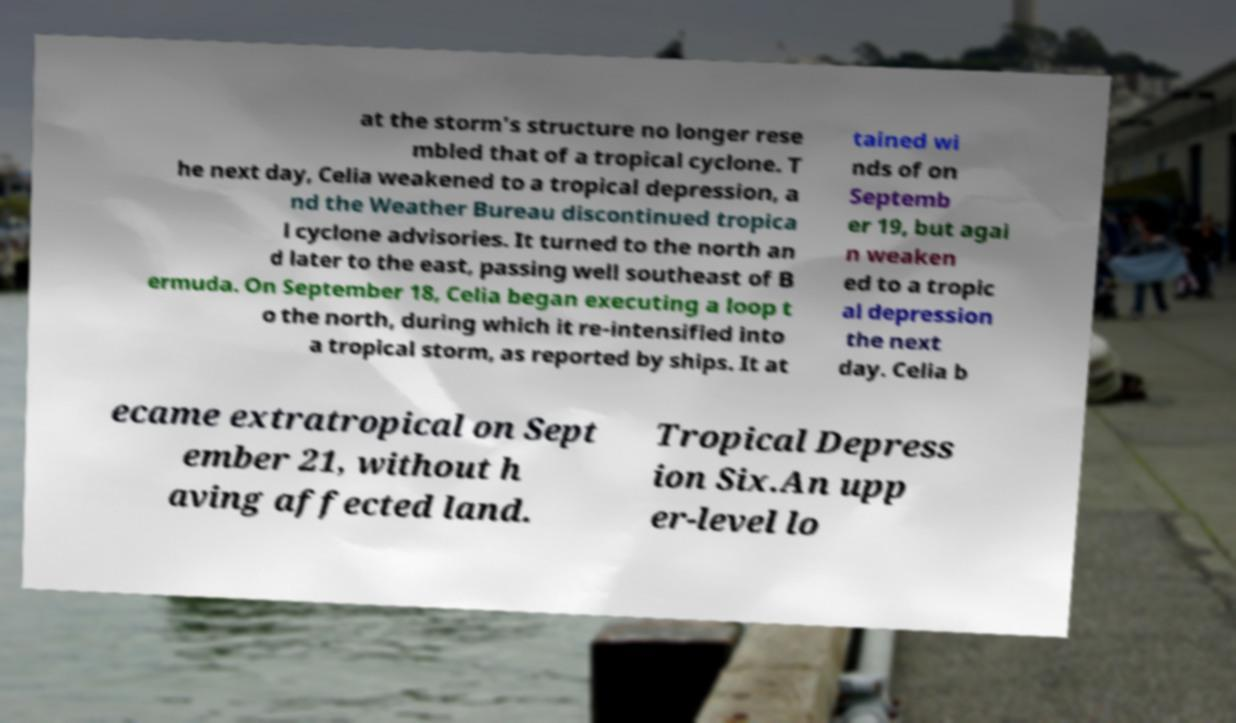Please identify and transcribe the text found in this image. at the storm's structure no longer rese mbled that of a tropical cyclone. T he next day, Celia weakened to a tropical depression, a nd the Weather Bureau discontinued tropica l cyclone advisories. It turned to the north an d later to the east, passing well southeast of B ermuda. On September 18, Celia began executing a loop t o the north, during which it re-intensified into a tropical storm, as reported by ships. It at tained wi nds of on Septemb er 19, but agai n weaken ed to a tropic al depression the next day. Celia b ecame extratropical on Sept ember 21, without h aving affected land. Tropical Depress ion Six.An upp er-level lo 